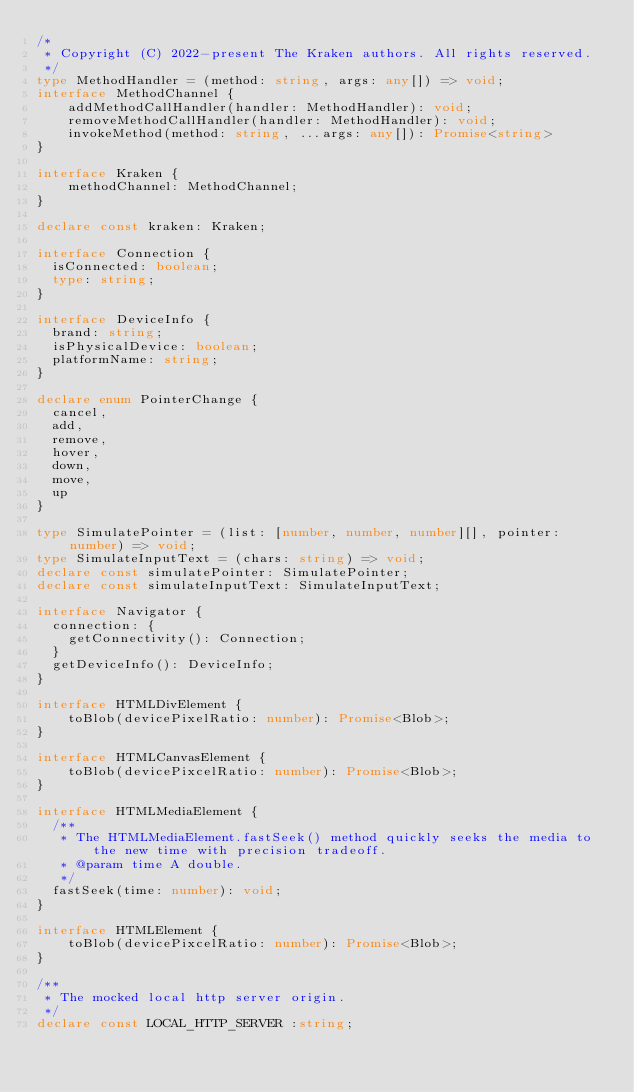<code> <loc_0><loc_0><loc_500><loc_500><_TypeScript_>/*
 * Copyright (C) 2022-present The Kraken authors. All rights reserved.
 */
type MethodHandler = (method: string, args: any[]) => void;
interface MethodChannel {
    addMethodCallHandler(handler: MethodHandler): void;
    removeMethodCallHandler(handler: MethodHandler): void;
    invokeMethod(method: string, ...args: any[]): Promise<string>
}

interface Kraken {
    methodChannel: MethodChannel;
}

declare const kraken: Kraken;

interface Connection {
  isConnected: boolean;
  type: string;
}

interface DeviceInfo {
  brand: string;
  isPhysicalDevice: boolean;
  platformName: string;
}

declare enum PointerChange {
  cancel,
  add,
  remove,
  hover,
  down,
  move,
  up
}

type SimulatePointer = (list: [number, number, number][], pointer: number) => void;
type SimulateInputText = (chars: string) => void;
declare const simulatePointer: SimulatePointer;
declare const simulateInputText: SimulateInputText;

interface Navigator {
  connection: {
    getConnectivity(): Connection;
  }
  getDeviceInfo(): DeviceInfo;
}

interface HTMLDivElement {
    toBlob(devicePixelRatio: number): Promise<Blob>;
}

interface HTMLCanvasElement {
    toBlob(devicePixcelRatio: number): Promise<Blob>;
}

interface HTMLMediaElement {
  /**
   * The HTMLMediaElement.fastSeek() method quickly seeks the media to the new time with precision tradeoff.
   * @param time A double.
   */
  fastSeek(time: number): void;
}

interface HTMLElement {
    toBlob(devicePixcelRatio: number): Promise<Blob>;
}

/**
 * The mocked local http server origin.
 */
declare const LOCAL_HTTP_SERVER :string;
</code> 